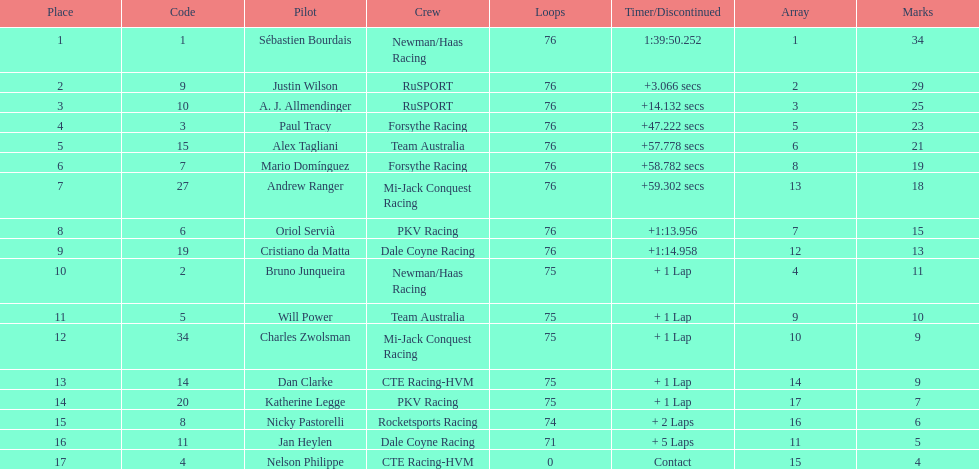Which canadian driver finished first: alex tagliani or paul tracy? Paul Tracy. 